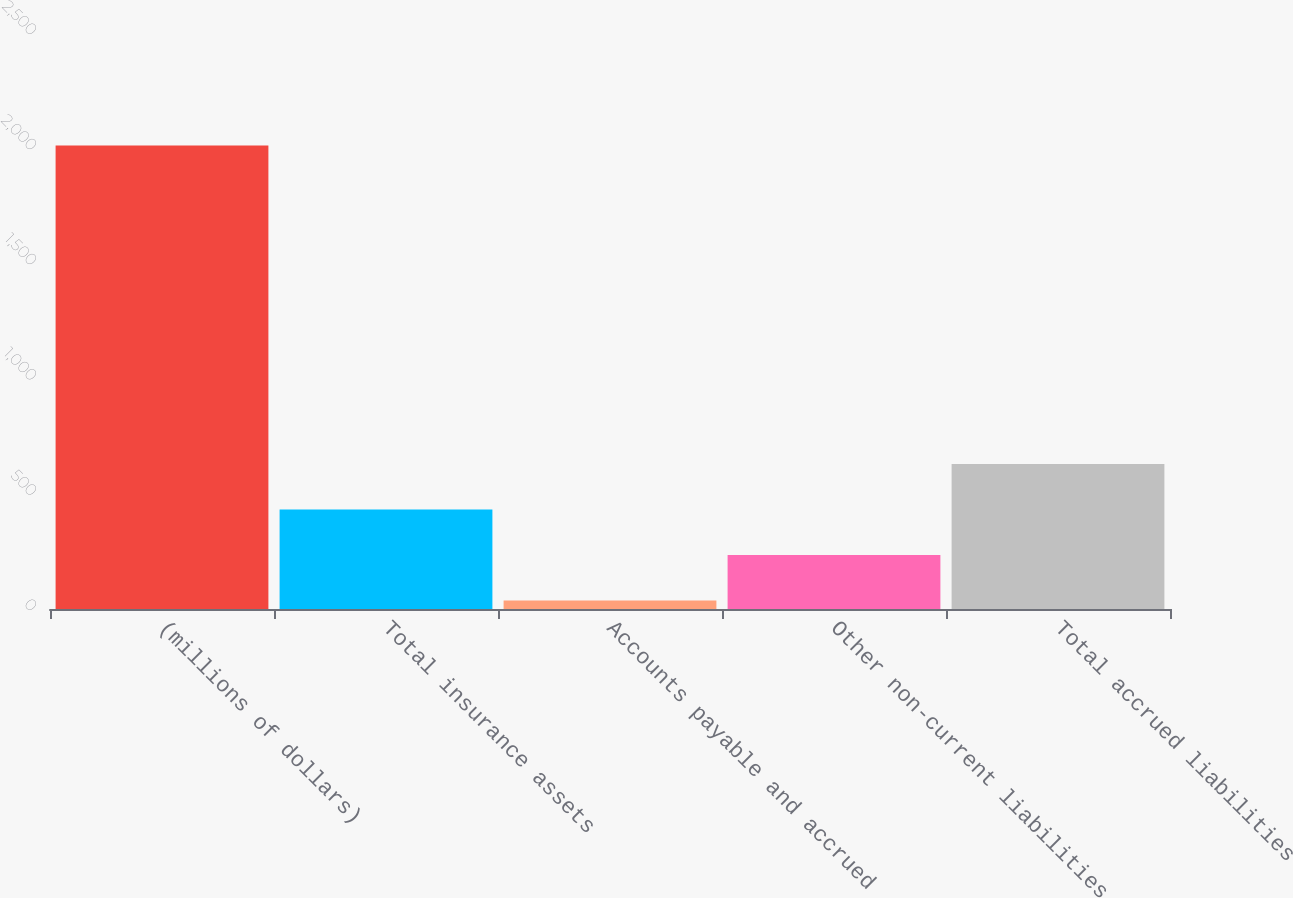Convert chart to OTSL. <chart><loc_0><loc_0><loc_500><loc_500><bar_chart><fcel>(millions of dollars)<fcel>Total insurance assets<fcel>Accounts payable and accrued<fcel>Other non-current liabilities<fcel>Total accrued liabilities<nl><fcel>2012<fcel>431.6<fcel>36.5<fcel>234.05<fcel>629.15<nl></chart> 